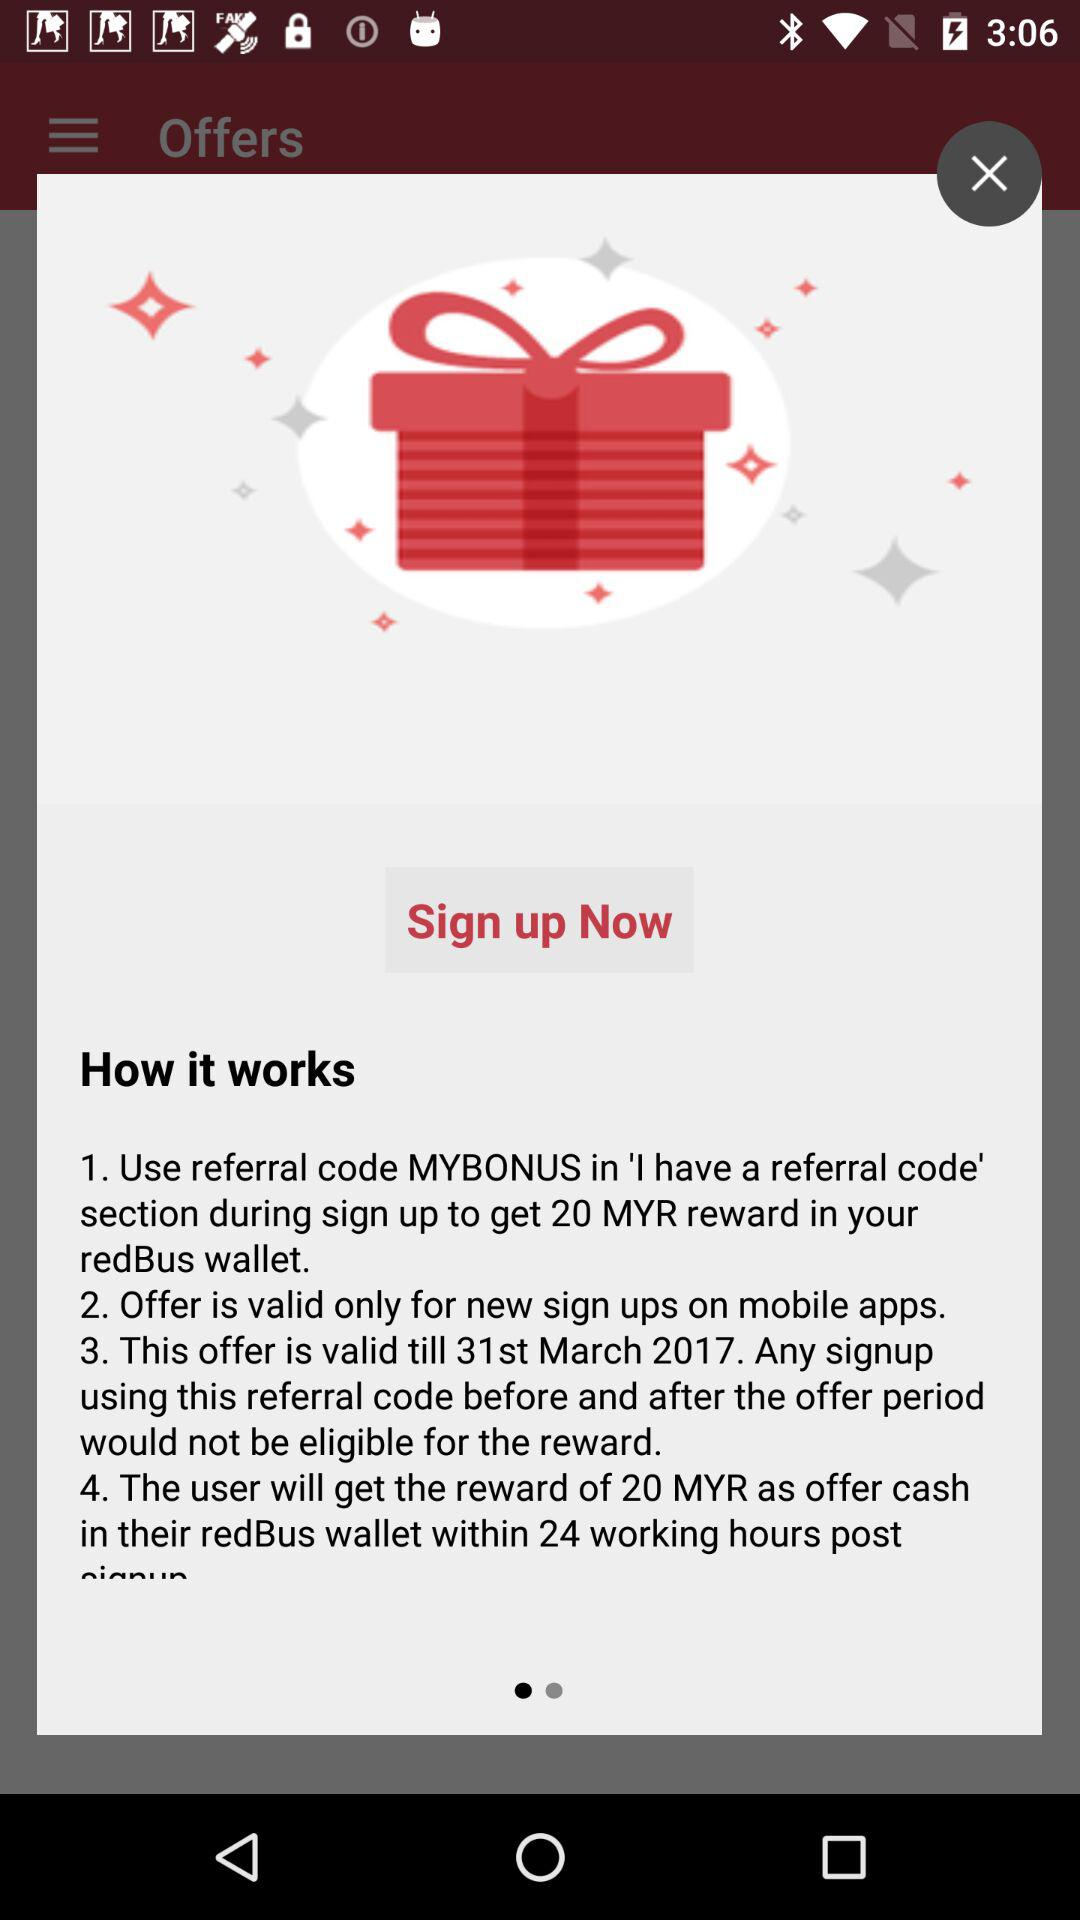How many steps are there in the 'How it works' section?
Answer the question using a single word or phrase. 4 